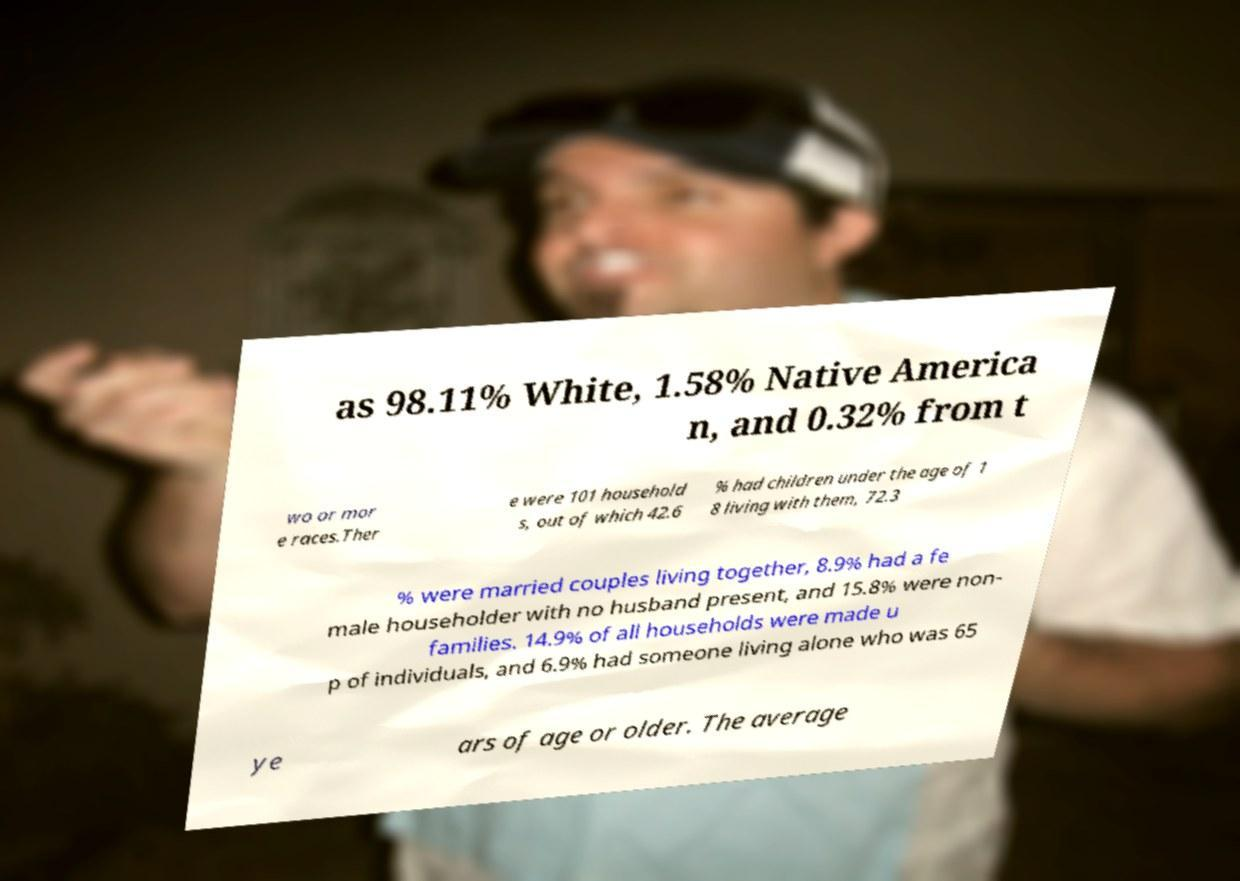Could you extract and type out the text from this image? as 98.11% White, 1.58% Native America n, and 0.32% from t wo or mor e races.Ther e were 101 household s, out of which 42.6 % had children under the age of 1 8 living with them, 72.3 % were married couples living together, 8.9% had a fe male householder with no husband present, and 15.8% were non- families. 14.9% of all households were made u p of individuals, and 6.9% had someone living alone who was 65 ye ars of age or older. The average 